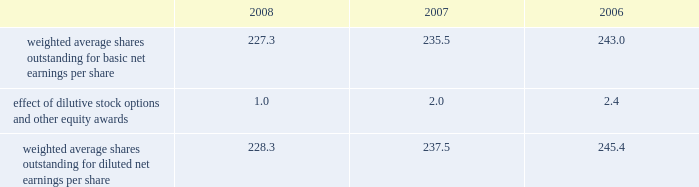Reasonably possible that such matters will be resolved in the next twelve months , but we do not anticipate that the resolution of these matters would result in any material impact on our results of operations or financial position .
Foreign jurisdictions have statutes of limitations generally ranging from 3 to 5 years .
Years still open to examination by foreign tax authorities in major jurisdictions include australia ( 2003 onward ) , canada ( 2002 onward ) , france ( 2006 onward ) , germany ( 2005 onward ) , italy ( 2005 onward ) , japan ( 2002 onward ) , puerto rico ( 2005 onward ) , singapore ( 2003 onward ) , switzerland ( 2006 onward ) and the united kingdom ( 2006 onward ) .
Our tax returns are currently under examination in various foreign jurisdictions .
The most significant foreign tax jurisdiction under examination is the united kingdom .
It is reasonably possible that such audits will be resolved in the next twelve months , but we do not anticipate that the resolution of these audits would result in any material impact on our results of operations or financial position .
13 .
Capital stock and earnings per share we are authorized to issue 250 million shares of preferred stock , none of which were issued or outstanding as of december 31 , 2008 .
The numerator for both basic and diluted earnings per share is net earnings available to common stockholders .
The denominator for basic earnings per share is the weighted average number of common shares outstanding during the period .
The denominator for diluted earnings per share is weighted average shares outstanding adjusted for the effect of dilutive stock options and other equity awards .
The following is a reconciliation of weighted average shares for the basic and diluted share computations for the years ending december 31 ( in millions ) : .
Weighted average shares outstanding for basic net earnings per share 227.3 235.5 243.0 effect of dilutive stock options and other equity awards 1.0 2.0 2.4 weighted average shares outstanding for diluted net earnings per share 228.3 237.5 245.4 for the year ended december 31 , 2008 , an average of 11.2 million options to purchase shares of common stock were not included in the computation of diluted earnings per share as the exercise prices of these options were greater than the average market price of the common stock .
For the years ended december 31 , 2007 and 2006 , an average of 3.1 million and 7.6 million options , respectively , were not included .
During 2008 , we repurchased approximately 10.8 million shares of our common stock at an average price of $ 68.72 per share for a total cash outlay of $ 737.0 million , including commissions .
In april 2008 , we announced that our board of directors authorized a $ 1.25 billion share repurchase program which expires december 31 , 2009 .
Approximately $ 1.13 billion remains authorized under this plan .
14 .
Segment data we design , develop , manufacture and market orthopaedic and dental reconstructive implants , spinal implants , trauma products and related surgical products which include surgical supplies and instruments designed to aid in orthopaedic surgical procedures and post-operation rehabilitation .
We also provide other healthcare-related services .
Revenue related to these services currently represents less than 1 percent of our total net sales .
We manage operations through three major geographic segments 2013 the americas , which is comprised principally of the united states and includes other north , central and south american markets ; europe , which is comprised principally of europe and includes the middle east and africa ; and asia pacific , which is comprised primarily of japan and includes other asian and pacific markets .
This structure is the basis for our reportable segment information discussed below .
Management evaluates operating segment performance based upon segment operating profit exclusive of operating expenses pertaining to global operations and corporate expenses , share-based compensation expense , settlement , certain claims , acquisition , integration and other expenses , inventory step-up , in-process research and development write-offs and intangible asset amortization expense .
Global operations include research , development engineering , medical education , brand management , corporate legal , finance , and human resource functions , and u.s .
And puerto rico-based manufacturing operations and logistics .
Intercompany transactions have been eliminated from segment operating profit .
Management reviews accounts receivable , inventory , property , plant and equipment , goodwill and intangible assets by reportable segment exclusive of u.s and puerto rico-based manufacturing operations and logistics and corporate assets .
Z i m m e r h o l d i n g s , i n c .
2 0 0 8 f o r m 1 0 - k a n n u a l r e p o r t notes to consolidated financial statements ( continued ) %%transmsg*** transmitting job : c48761 pcn : 058000000 ***%%pcmsg|58 |00011|yes|no|02/24/2009 19:25|0|0|page is valid , no graphics -- color : d| .
What was the percentage change in weighted average shares outstanding for diluted net earnings per share from 2006 to 2007? 
Computations: ((237.5 - 245.4) / 245.4)
Answer: -0.03219. 